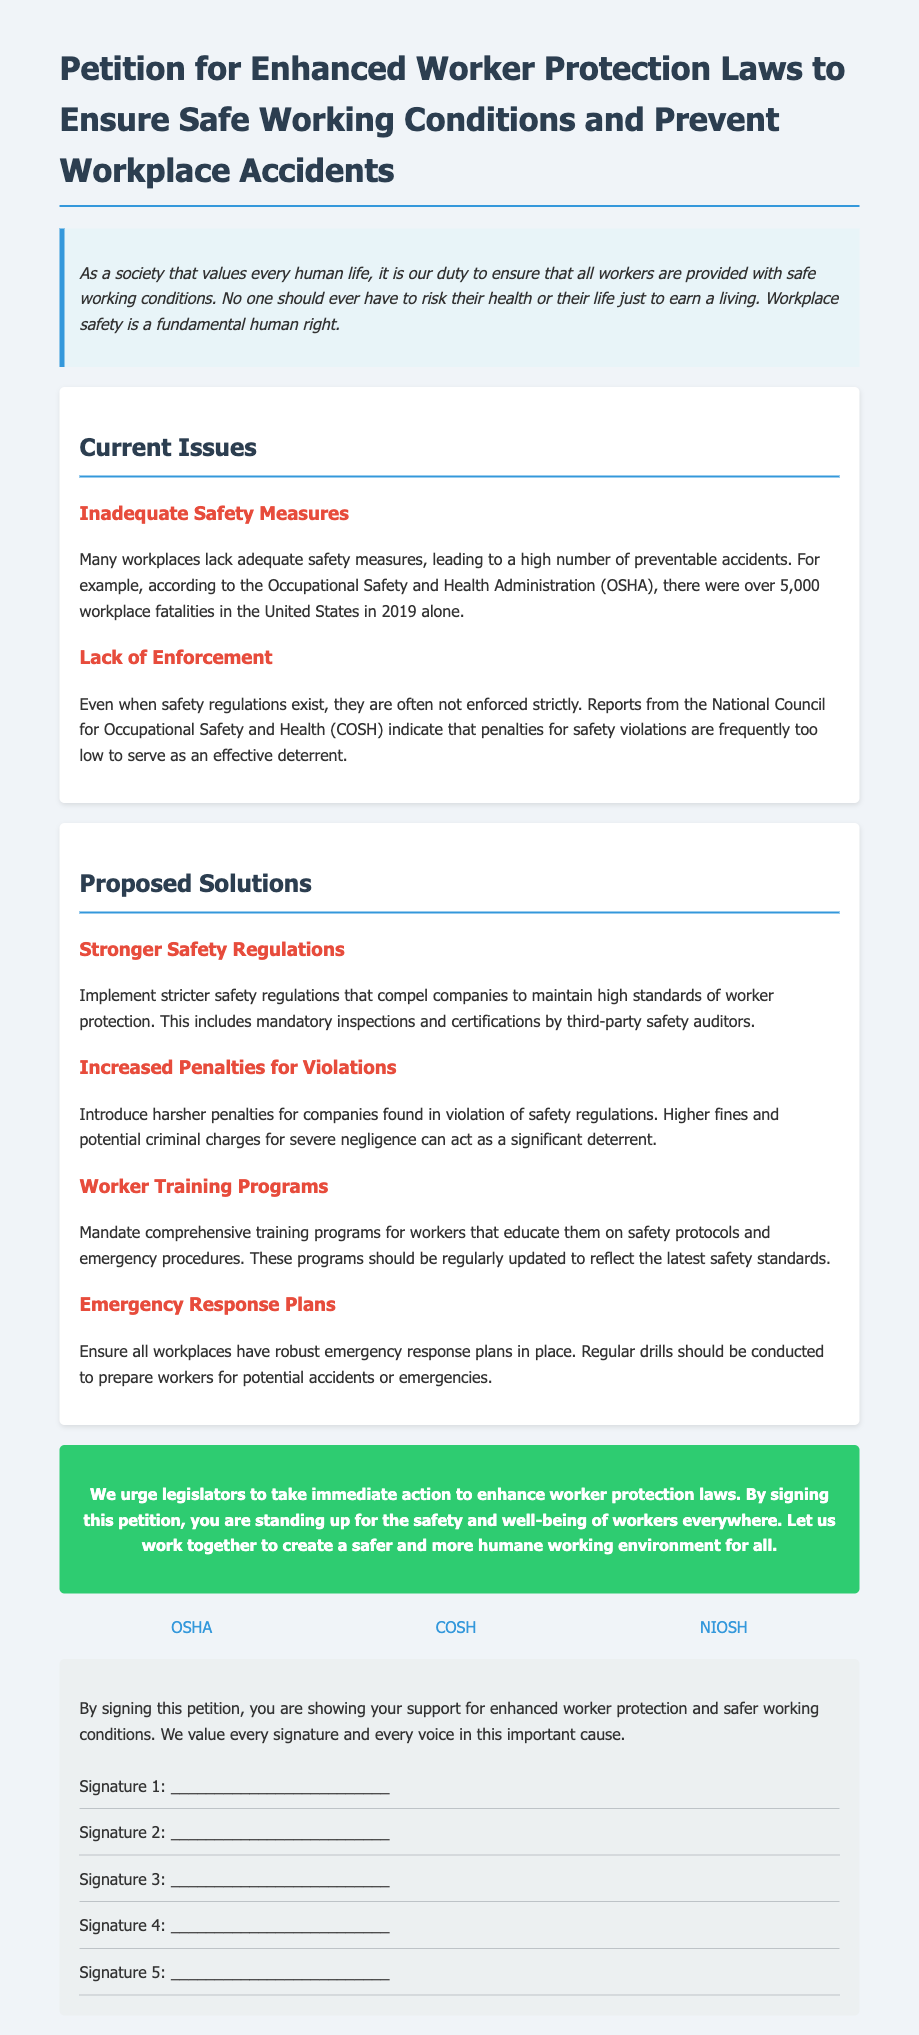What is the title of the petition? The title summarizes the main purpose of the document, which is to advocate for better worker protection laws.
Answer: Petition for Enhanced Worker Protection Laws to Ensure Safe Working Conditions and Prevent Workplace Accidents How many workplace fatalities were reported in the United States in 2019? The document states that this statistic highlights the need for improved safety measures and awareness around workplace conditions.
Answer: over 5,000 What organization is mentioned as overseeing workplace safety measures? This organization is referenced to support the case regarding inadequate safety measures in workplaces.
Answer: OSHA What is one of the proposed solutions for enhanced worker protection? The document lists this solution along with others that aim to mitigate safety risks for workers.
Answer: Stronger Safety Regulations What consequence is suggested for companies that violate safety regulations? This proposed measure aims to deter negligence through stricter accountability.
Answer: Increased Penalties for Violations What is the main call to action in the petition? This phrase emphasizes the urgency and importance of collective action for worker safety.
Answer: enhance worker protection laws How many signature lines are provided in the petition? The number of lines for signatures indicates the petition's intent to gather support from the community.
Answer: 5 What background color is used for the introductory paragraph? The color choice can reflect the tone and emphasis of the document's intent.
Answer: #e8f4f8 Which agency provides information about respiratory health in the document? This agency is cited to back the importance of health in workplace safety discussions.
Answer: NIOSH 